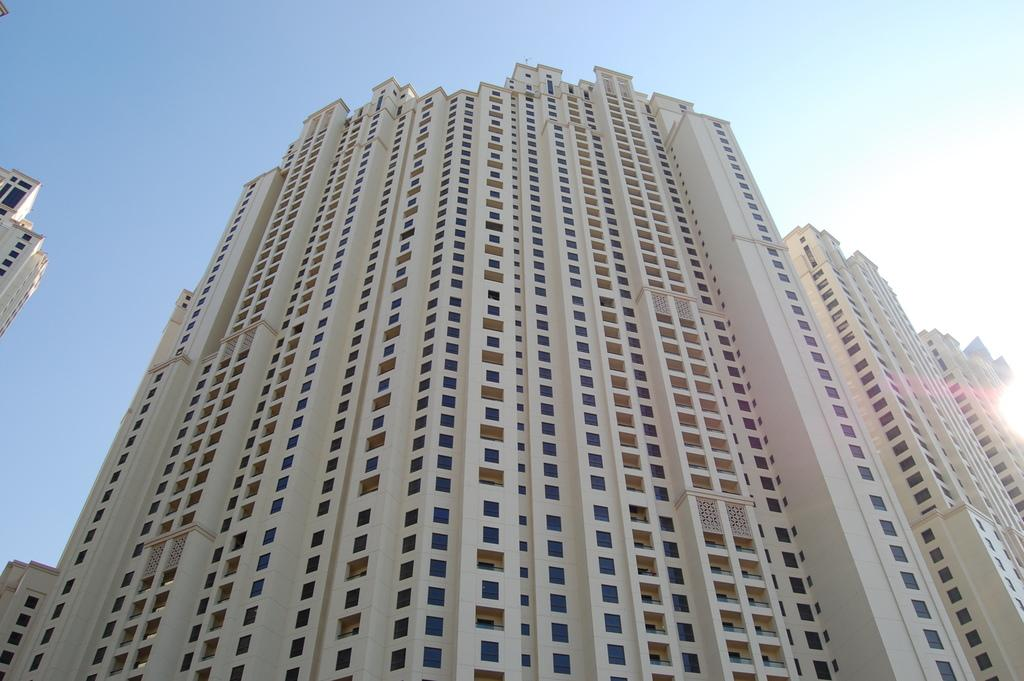What type of structures are present in the image? There are buildings in the image. What architectural feature can be seen on the buildings? Windows are visible in the image. What part of the natural environment is visible in the image? The sky is visible in the image. How many bikes are parked near the buildings in the image? There is no information about bikes in the image, so it cannot be determined how many might be present. What type of ring can be seen on the windows in the image? There are no rings visible on the windows in the image. 